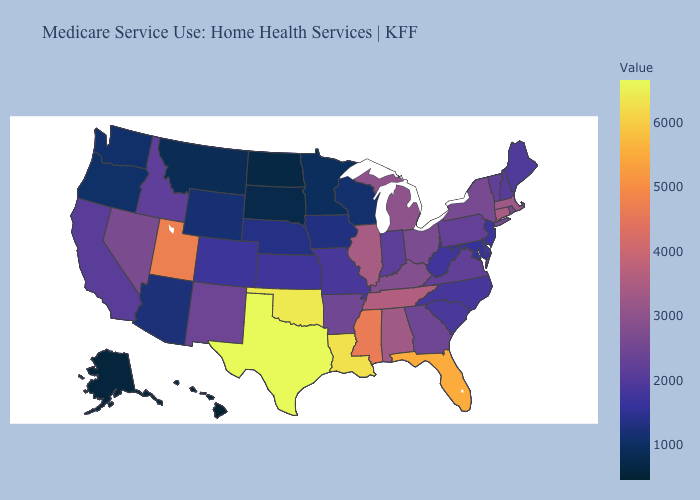Does New Jersey have a lower value than Oklahoma?
Short answer required. Yes. Does Hawaii have the lowest value in the USA?
Concise answer only. Yes. Which states have the lowest value in the West?
Write a very short answer. Hawaii. Is the legend a continuous bar?
Quick response, please. Yes. 